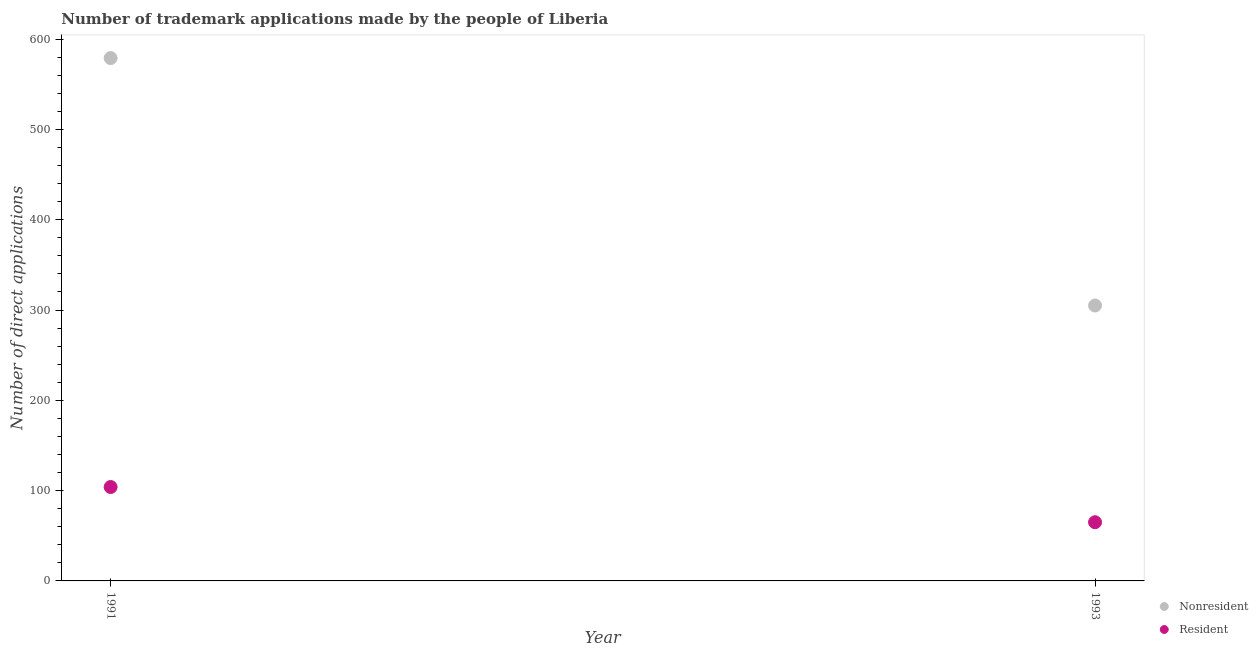How many different coloured dotlines are there?
Give a very brief answer. 2. Is the number of dotlines equal to the number of legend labels?
Provide a succinct answer. Yes. What is the number of trademark applications made by non residents in 1991?
Provide a succinct answer. 579. Across all years, what is the maximum number of trademark applications made by non residents?
Your answer should be compact. 579. Across all years, what is the minimum number of trademark applications made by residents?
Your answer should be compact. 65. In which year was the number of trademark applications made by residents minimum?
Offer a very short reply. 1993. What is the total number of trademark applications made by non residents in the graph?
Offer a very short reply. 884. What is the difference between the number of trademark applications made by residents in 1991 and that in 1993?
Your response must be concise. 39. What is the difference between the number of trademark applications made by non residents in 1993 and the number of trademark applications made by residents in 1991?
Ensure brevity in your answer.  201. What is the average number of trademark applications made by residents per year?
Provide a succinct answer. 84.5. In the year 1993, what is the difference between the number of trademark applications made by residents and number of trademark applications made by non residents?
Provide a succinct answer. -240. In how many years, is the number of trademark applications made by residents greater than 380?
Provide a short and direct response. 0. Is the number of trademark applications made by residents in 1991 less than that in 1993?
Your answer should be very brief. No. In how many years, is the number of trademark applications made by non residents greater than the average number of trademark applications made by non residents taken over all years?
Keep it short and to the point. 1. How many years are there in the graph?
Your answer should be compact. 2. Are the values on the major ticks of Y-axis written in scientific E-notation?
Provide a succinct answer. No. Does the graph contain grids?
Make the answer very short. No. How many legend labels are there?
Keep it short and to the point. 2. What is the title of the graph?
Your answer should be compact. Number of trademark applications made by the people of Liberia. Does "Borrowers" appear as one of the legend labels in the graph?
Give a very brief answer. No. What is the label or title of the Y-axis?
Offer a very short reply. Number of direct applications. What is the Number of direct applications in Nonresident in 1991?
Offer a terse response. 579. What is the Number of direct applications in Resident in 1991?
Provide a short and direct response. 104. What is the Number of direct applications in Nonresident in 1993?
Your response must be concise. 305. What is the Number of direct applications in Resident in 1993?
Your answer should be compact. 65. Across all years, what is the maximum Number of direct applications of Nonresident?
Your answer should be compact. 579. Across all years, what is the maximum Number of direct applications in Resident?
Your response must be concise. 104. Across all years, what is the minimum Number of direct applications of Nonresident?
Your response must be concise. 305. What is the total Number of direct applications of Nonresident in the graph?
Keep it short and to the point. 884. What is the total Number of direct applications in Resident in the graph?
Offer a terse response. 169. What is the difference between the Number of direct applications of Nonresident in 1991 and that in 1993?
Provide a succinct answer. 274. What is the difference between the Number of direct applications in Resident in 1991 and that in 1993?
Make the answer very short. 39. What is the difference between the Number of direct applications of Nonresident in 1991 and the Number of direct applications of Resident in 1993?
Give a very brief answer. 514. What is the average Number of direct applications in Nonresident per year?
Provide a short and direct response. 442. What is the average Number of direct applications in Resident per year?
Provide a succinct answer. 84.5. In the year 1991, what is the difference between the Number of direct applications in Nonresident and Number of direct applications in Resident?
Offer a terse response. 475. In the year 1993, what is the difference between the Number of direct applications of Nonresident and Number of direct applications of Resident?
Your response must be concise. 240. What is the ratio of the Number of direct applications of Nonresident in 1991 to that in 1993?
Offer a terse response. 1.9. What is the difference between the highest and the second highest Number of direct applications of Nonresident?
Your response must be concise. 274. What is the difference between the highest and the lowest Number of direct applications of Nonresident?
Give a very brief answer. 274. What is the difference between the highest and the lowest Number of direct applications of Resident?
Offer a very short reply. 39. 